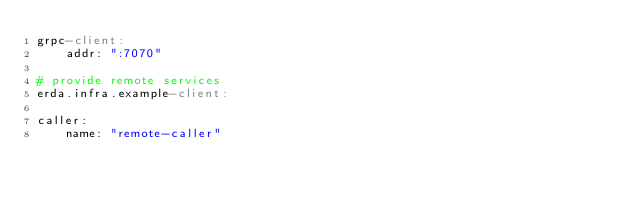Convert code to text. <code><loc_0><loc_0><loc_500><loc_500><_YAML_>grpc-client:
    addr: ":7070"

# provide remote services
erda.infra.example-client:

caller:
    name: "remote-caller"
</code> 